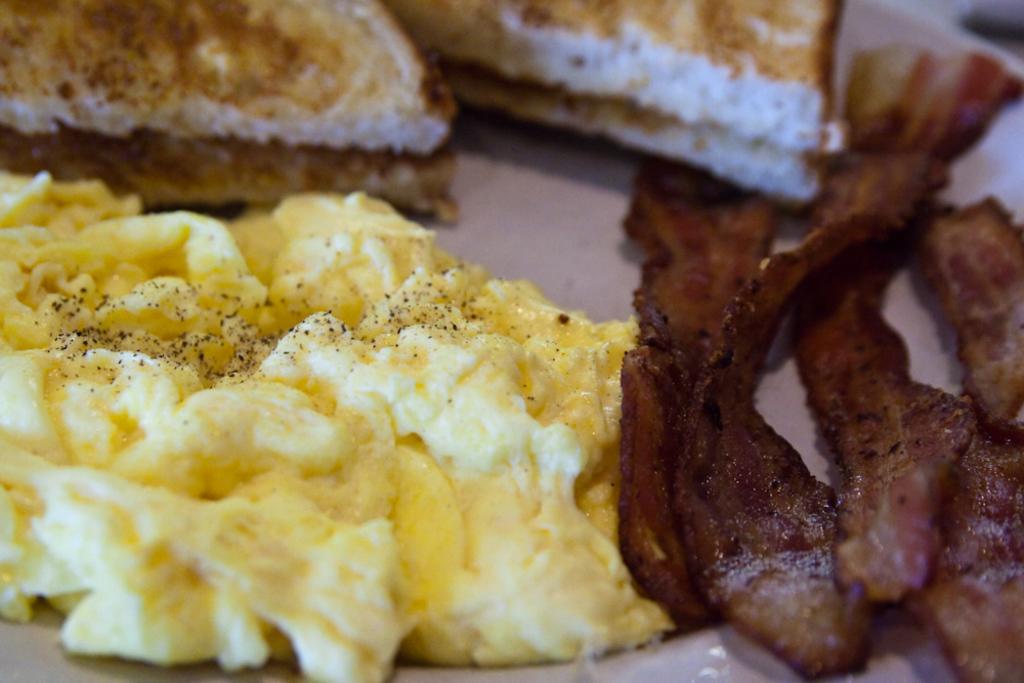In one or two sentences, can you explain what this image depicts? In this image I can see different types of food. I can also see colour of these food are yellow, brown and white. 